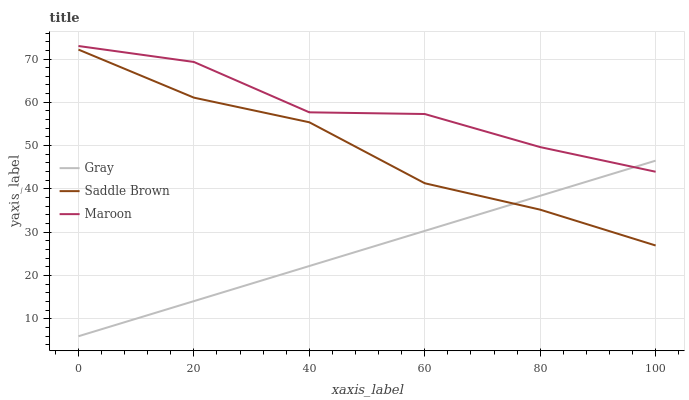Does Gray have the minimum area under the curve?
Answer yes or no. Yes. Does Maroon have the maximum area under the curve?
Answer yes or no. Yes. Does Saddle Brown have the minimum area under the curve?
Answer yes or no. No. Does Saddle Brown have the maximum area under the curve?
Answer yes or no. No. Is Gray the smoothest?
Answer yes or no. Yes. Is Maroon the roughest?
Answer yes or no. Yes. Is Saddle Brown the smoothest?
Answer yes or no. No. Is Saddle Brown the roughest?
Answer yes or no. No. Does Gray have the lowest value?
Answer yes or no. Yes. Does Saddle Brown have the lowest value?
Answer yes or no. No. Does Maroon have the highest value?
Answer yes or no. Yes. Does Saddle Brown have the highest value?
Answer yes or no. No. Is Saddle Brown less than Maroon?
Answer yes or no. Yes. Is Maroon greater than Saddle Brown?
Answer yes or no. Yes. Does Gray intersect Saddle Brown?
Answer yes or no. Yes. Is Gray less than Saddle Brown?
Answer yes or no. No. Is Gray greater than Saddle Brown?
Answer yes or no. No. Does Saddle Brown intersect Maroon?
Answer yes or no. No. 